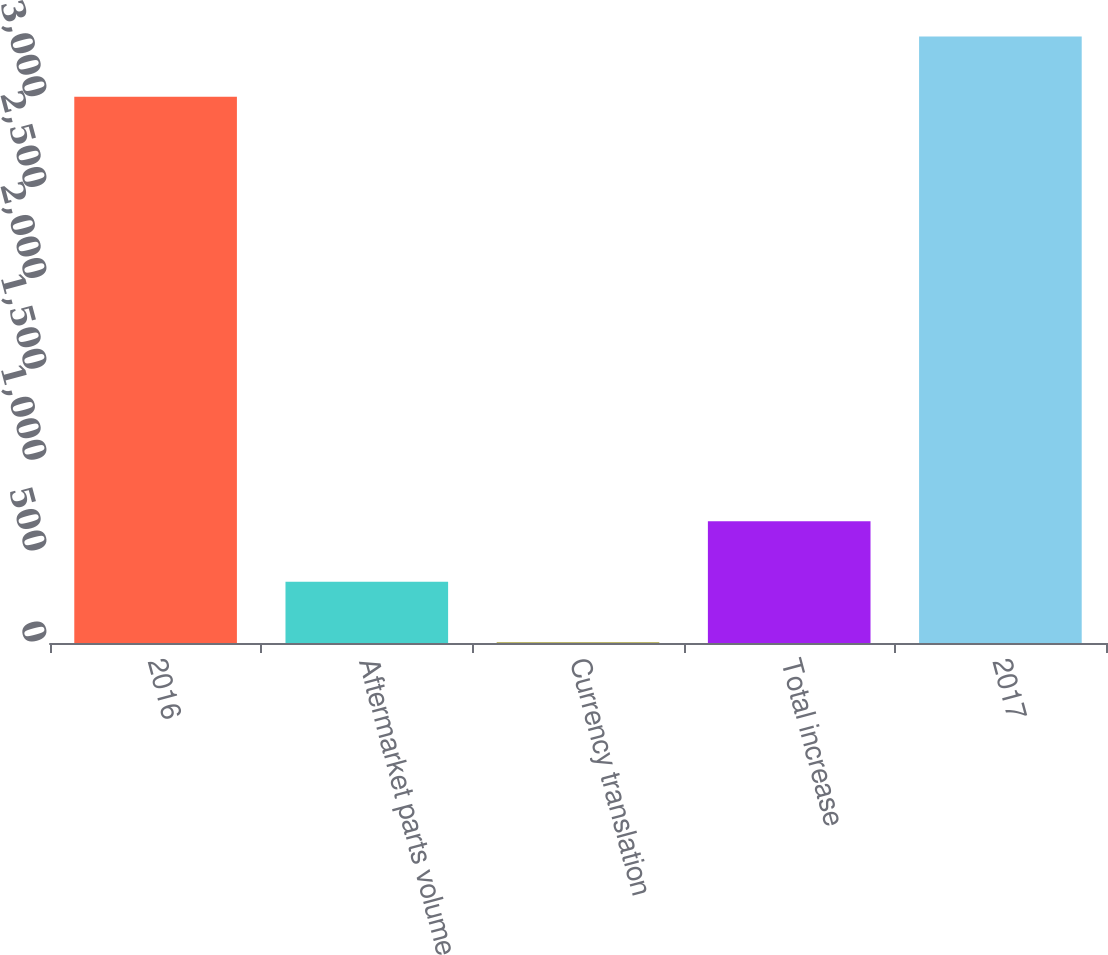Convert chart. <chart><loc_0><loc_0><loc_500><loc_500><bar_chart><fcel>2016<fcel>Aftermarket parts volume<fcel>Currency translation<fcel>Total increase<fcel>2017<nl><fcel>3005.7<fcel>337.56<fcel>5.4<fcel>669.72<fcel>3337.86<nl></chart> 